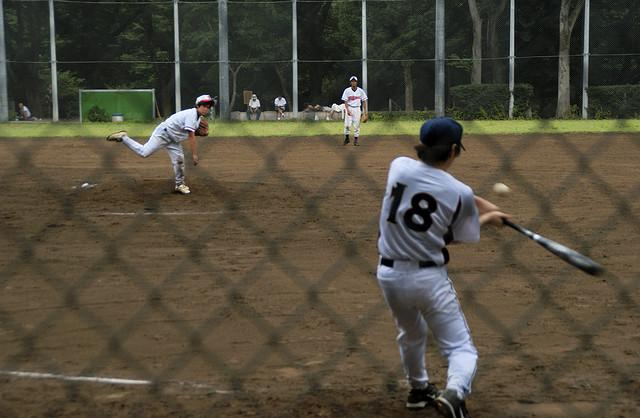Who will next cause the balls direction to change?

Choices:
A) 18
B) pitcher
C) coach
D) shortstop 18 